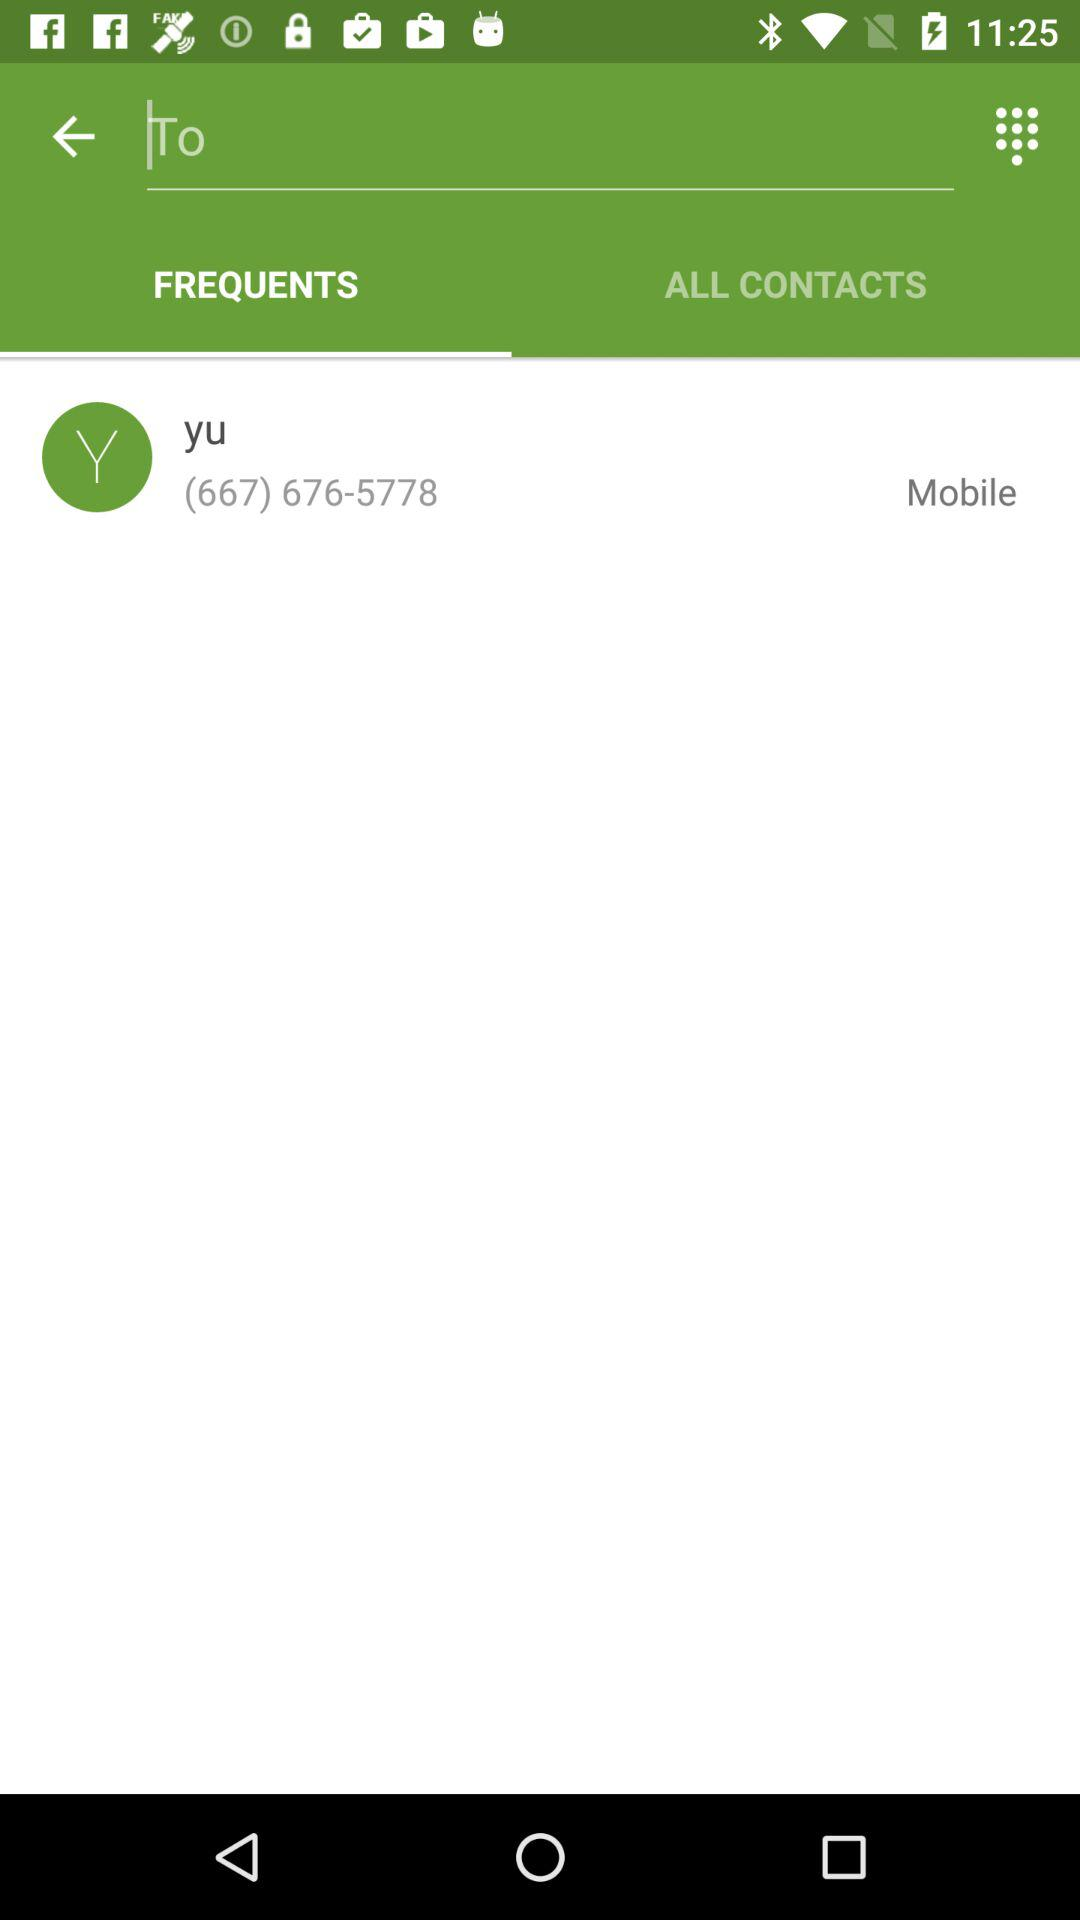What is the name of the contact number holder? The name of the contact number holder is "yu". 